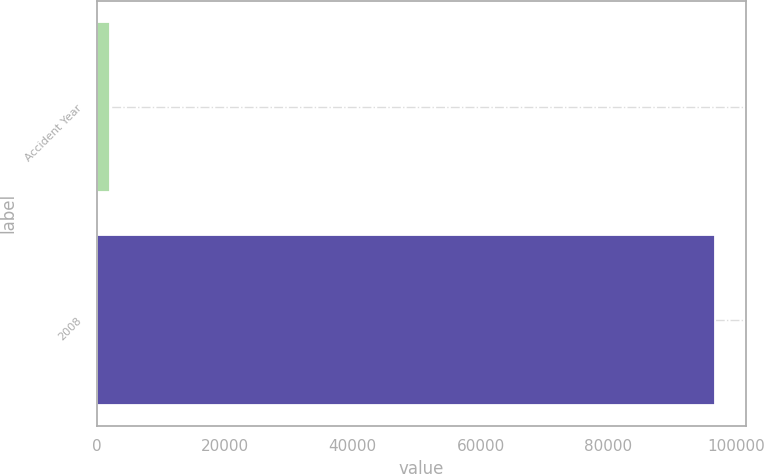Convert chart. <chart><loc_0><loc_0><loc_500><loc_500><bar_chart><fcel>Accident Year<fcel>2008<nl><fcel>2012<fcel>96621<nl></chart> 